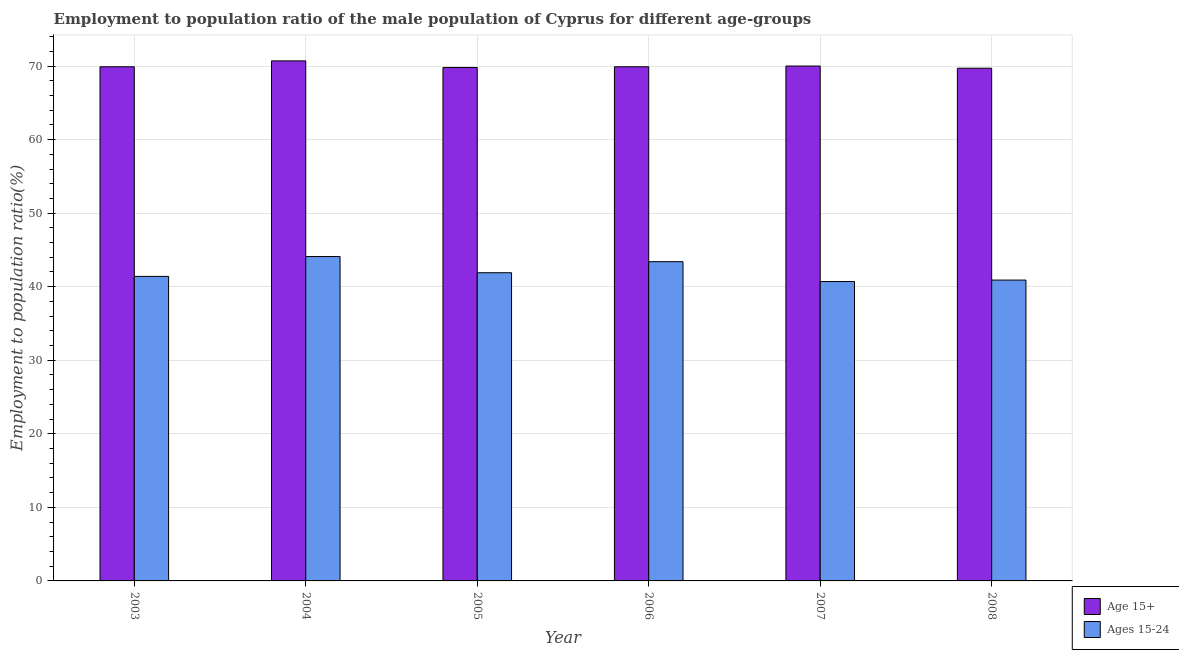How many different coloured bars are there?
Give a very brief answer. 2. Are the number of bars per tick equal to the number of legend labels?
Provide a succinct answer. Yes. Are the number of bars on each tick of the X-axis equal?
Provide a succinct answer. Yes. How many bars are there on the 3rd tick from the left?
Ensure brevity in your answer.  2. What is the label of the 2nd group of bars from the left?
Your response must be concise. 2004. What is the employment to population ratio(age 15+) in 2007?
Your answer should be very brief. 70. Across all years, what is the maximum employment to population ratio(age 15+)?
Make the answer very short. 70.7. Across all years, what is the minimum employment to population ratio(age 15-24)?
Your answer should be compact. 40.7. In which year was the employment to population ratio(age 15-24) minimum?
Give a very brief answer. 2007. What is the total employment to population ratio(age 15-24) in the graph?
Your answer should be compact. 252.4. What is the difference between the employment to population ratio(age 15+) in 2005 and that in 2006?
Keep it short and to the point. -0.1. What is the average employment to population ratio(age 15-24) per year?
Offer a terse response. 42.07. In the year 2003, what is the difference between the employment to population ratio(age 15-24) and employment to population ratio(age 15+)?
Offer a terse response. 0. In how many years, is the employment to population ratio(age 15-24) greater than 18 %?
Provide a succinct answer. 6. What is the ratio of the employment to population ratio(age 15-24) in 2004 to that in 2008?
Your answer should be very brief. 1.08. Is the employment to population ratio(age 15-24) in 2003 less than that in 2004?
Make the answer very short. Yes. Is the difference between the employment to population ratio(age 15+) in 2003 and 2004 greater than the difference between the employment to population ratio(age 15-24) in 2003 and 2004?
Keep it short and to the point. No. What is the difference between the highest and the second highest employment to population ratio(age 15+)?
Make the answer very short. 0.7. What is the difference between the highest and the lowest employment to population ratio(age 15-24)?
Provide a succinct answer. 3.4. What does the 1st bar from the left in 2005 represents?
Your answer should be very brief. Age 15+. What does the 1st bar from the right in 2007 represents?
Your response must be concise. Ages 15-24. Are all the bars in the graph horizontal?
Your response must be concise. No. How many years are there in the graph?
Provide a short and direct response. 6. Where does the legend appear in the graph?
Your response must be concise. Bottom right. What is the title of the graph?
Provide a succinct answer. Employment to population ratio of the male population of Cyprus for different age-groups. Does "UN agencies" appear as one of the legend labels in the graph?
Provide a short and direct response. No. What is the label or title of the X-axis?
Provide a succinct answer. Year. What is the label or title of the Y-axis?
Make the answer very short. Employment to population ratio(%). What is the Employment to population ratio(%) in Age 15+ in 2003?
Provide a succinct answer. 69.9. What is the Employment to population ratio(%) in Ages 15-24 in 2003?
Provide a short and direct response. 41.4. What is the Employment to population ratio(%) of Age 15+ in 2004?
Make the answer very short. 70.7. What is the Employment to population ratio(%) in Ages 15-24 in 2004?
Give a very brief answer. 44.1. What is the Employment to population ratio(%) of Age 15+ in 2005?
Provide a short and direct response. 69.8. What is the Employment to population ratio(%) in Ages 15-24 in 2005?
Your answer should be compact. 41.9. What is the Employment to population ratio(%) in Age 15+ in 2006?
Ensure brevity in your answer.  69.9. What is the Employment to population ratio(%) in Ages 15-24 in 2006?
Ensure brevity in your answer.  43.4. What is the Employment to population ratio(%) in Age 15+ in 2007?
Ensure brevity in your answer.  70. What is the Employment to population ratio(%) of Ages 15-24 in 2007?
Give a very brief answer. 40.7. What is the Employment to population ratio(%) of Age 15+ in 2008?
Provide a short and direct response. 69.7. What is the Employment to population ratio(%) in Ages 15-24 in 2008?
Offer a terse response. 40.9. Across all years, what is the maximum Employment to population ratio(%) in Age 15+?
Your response must be concise. 70.7. Across all years, what is the maximum Employment to population ratio(%) in Ages 15-24?
Provide a succinct answer. 44.1. Across all years, what is the minimum Employment to population ratio(%) of Age 15+?
Your answer should be very brief. 69.7. Across all years, what is the minimum Employment to population ratio(%) in Ages 15-24?
Your answer should be compact. 40.7. What is the total Employment to population ratio(%) of Age 15+ in the graph?
Your answer should be compact. 420. What is the total Employment to population ratio(%) in Ages 15-24 in the graph?
Give a very brief answer. 252.4. What is the difference between the Employment to population ratio(%) in Age 15+ in 2003 and that in 2004?
Give a very brief answer. -0.8. What is the difference between the Employment to population ratio(%) in Ages 15-24 in 2003 and that in 2006?
Your answer should be very brief. -2. What is the difference between the Employment to population ratio(%) of Age 15+ in 2004 and that in 2005?
Your response must be concise. 0.9. What is the difference between the Employment to population ratio(%) of Ages 15-24 in 2004 and that in 2006?
Offer a terse response. 0.7. What is the difference between the Employment to population ratio(%) of Age 15+ in 2004 and that in 2007?
Offer a very short reply. 0.7. What is the difference between the Employment to population ratio(%) in Age 15+ in 2004 and that in 2008?
Your response must be concise. 1. What is the difference between the Employment to population ratio(%) of Ages 15-24 in 2004 and that in 2008?
Provide a succinct answer. 3.2. What is the difference between the Employment to population ratio(%) in Ages 15-24 in 2005 and that in 2006?
Offer a very short reply. -1.5. What is the difference between the Employment to population ratio(%) in Age 15+ in 2005 and that in 2007?
Provide a short and direct response. -0.2. What is the difference between the Employment to population ratio(%) of Age 15+ in 2005 and that in 2008?
Keep it short and to the point. 0.1. What is the difference between the Employment to population ratio(%) in Ages 15-24 in 2006 and that in 2007?
Make the answer very short. 2.7. What is the difference between the Employment to population ratio(%) in Age 15+ in 2006 and that in 2008?
Keep it short and to the point. 0.2. What is the difference between the Employment to population ratio(%) of Age 15+ in 2003 and the Employment to population ratio(%) of Ages 15-24 in 2004?
Make the answer very short. 25.8. What is the difference between the Employment to population ratio(%) of Age 15+ in 2003 and the Employment to population ratio(%) of Ages 15-24 in 2007?
Your answer should be very brief. 29.2. What is the difference between the Employment to population ratio(%) in Age 15+ in 2004 and the Employment to population ratio(%) in Ages 15-24 in 2005?
Ensure brevity in your answer.  28.8. What is the difference between the Employment to population ratio(%) in Age 15+ in 2004 and the Employment to population ratio(%) in Ages 15-24 in 2006?
Provide a short and direct response. 27.3. What is the difference between the Employment to population ratio(%) in Age 15+ in 2004 and the Employment to population ratio(%) in Ages 15-24 in 2008?
Offer a terse response. 29.8. What is the difference between the Employment to population ratio(%) of Age 15+ in 2005 and the Employment to population ratio(%) of Ages 15-24 in 2006?
Provide a succinct answer. 26.4. What is the difference between the Employment to population ratio(%) in Age 15+ in 2005 and the Employment to population ratio(%) in Ages 15-24 in 2007?
Your response must be concise. 29.1. What is the difference between the Employment to population ratio(%) of Age 15+ in 2005 and the Employment to population ratio(%) of Ages 15-24 in 2008?
Provide a short and direct response. 28.9. What is the difference between the Employment to population ratio(%) in Age 15+ in 2006 and the Employment to population ratio(%) in Ages 15-24 in 2007?
Your response must be concise. 29.2. What is the difference between the Employment to population ratio(%) in Age 15+ in 2006 and the Employment to population ratio(%) in Ages 15-24 in 2008?
Provide a succinct answer. 29. What is the difference between the Employment to population ratio(%) of Age 15+ in 2007 and the Employment to population ratio(%) of Ages 15-24 in 2008?
Make the answer very short. 29.1. What is the average Employment to population ratio(%) of Age 15+ per year?
Make the answer very short. 70. What is the average Employment to population ratio(%) in Ages 15-24 per year?
Keep it short and to the point. 42.07. In the year 2004, what is the difference between the Employment to population ratio(%) in Age 15+ and Employment to population ratio(%) in Ages 15-24?
Provide a succinct answer. 26.6. In the year 2005, what is the difference between the Employment to population ratio(%) in Age 15+ and Employment to population ratio(%) in Ages 15-24?
Keep it short and to the point. 27.9. In the year 2006, what is the difference between the Employment to population ratio(%) in Age 15+ and Employment to population ratio(%) in Ages 15-24?
Provide a short and direct response. 26.5. In the year 2007, what is the difference between the Employment to population ratio(%) of Age 15+ and Employment to population ratio(%) of Ages 15-24?
Offer a terse response. 29.3. In the year 2008, what is the difference between the Employment to population ratio(%) of Age 15+ and Employment to population ratio(%) of Ages 15-24?
Ensure brevity in your answer.  28.8. What is the ratio of the Employment to population ratio(%) of Age 15+ in 2003 to that in 2004?
Make the answer very short. 0.99. What is the ratio of the Employment to population ratio(%) of Ages 15-24 in 2003 to that in 2004?
Keep it short and to the point. 0.94. What is the ratio of the Employment to population ratio(%) in Ages 15-24 in 2003 to that in 2005?
Provide a short and direct response. 0.99. What is the ratio of the Employment to population ratio(%) in Age 15+ in 2003 to that in 2006?
Your answer should be very brief. 1. What is the ratio of the Employment to population ratio(%) in Ages 15-24 in 2003 to that in 2006?
Your answer should be very brief. 0.95. What is the ratio of the Employment to population ratio(%) in Ages 15-24 in 2003 to that in 2007?
Your response must be concise. 1.02. What is the ratio of the Employment to population ratio(%) of Age 15+ in 2003 to that in 2008?
Offer a terse response. 1. What is the ratio of the Employment to population ratio(%) in Ages 15-24 in 2003 to that in 2008?
Offer a terse response. 1.01. What is the ratio of the Employment to population ratio(%) of Age 15+ in 2004 to that in 2005?
Provide a short and direct response. 1.01. What is the ratio of the Employment to population ratio(%) in Ages 15-24 in 2004 to that in 2005?
Your response must be concise. 1.05. What is the ratio of the Employment to population ratio(%) of Age 15+ in 2004 to that in 2006?
Provide a succinct answer. 1.01. What is the ratio of the Employment to population ratio(%) of Ages 15-24 in 2004 to that in 2006?
Offer a terse response. 1.02. What is the ratio of the Employment to population ratio(%) in Ages 15-24 in 2004 to that in 2007?
Make the answer very short. 1.08. What is the ratio of the Employment to population ratio(%) in Age 15+ in 2004 to that in 2008?
Keep it short and to the point. 1.01. What is the ratio of the Employment to population ratio(%) in Ages 15-24 in 2004 to that in 2008?
Your response must be concise. 1.08. What is the ratio of the Employment to population ratio(%) in Age 15+ in 2005 to that in 2006?
Offer a terse response. 1. What is the ratio of the Employment to population ratio(%) of Ages 15-24 in 2005 to that in 2006?
Provide a succinct answer. 0.97. What is the ratio of the Employment to population ratio(%) of Ages 15-24 in 2005 to that in 2007?
Provide a succinct answer. 1.03. What is the ratio of the Employment to population ratio(%) in Age 15+ in 2005 to that in 2008?
Offer a very short reply. 1. What is the ratio of the Employment to population ratio(%) in Ages 15-24 in 2005 to that in 2008?
Ensure brevity in your answer.  1.02. What is the ratio of the Employment to population ratio(%) in Age 15+ in 2006 to that in 2007?
Keep it short and to the point. 1. What is the ratio of the Employment to population ratio(%) in Ages 15-24 in 2006 to that in 2007?
Your response must be concise. 1.07. What is the ratio of the Employment to population ratio(%) in Age 15+ in 2006 to that in 2008?
Keep it short and to the point. 1. What is the ratio of the Employment to population ratio(%) of Ages 15-24 in 2006 to that in 2008?
Make the answer very short. 1.06. What is the difference between the highest and the second highest Employment to population ratio(%) of Age 15+?
Offer a terse response. 0.7. What is the difference between the highest and the second highest Employment to population ratio(%) in Ages 15-24?
Ensure brevity in your answer.  0.7. 